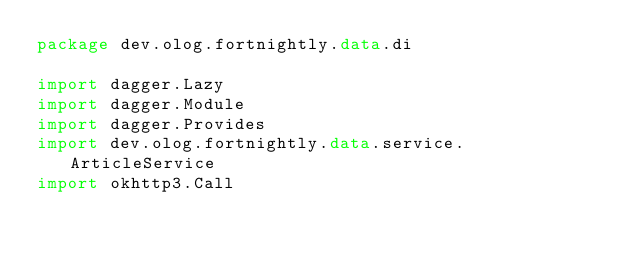<code> <loc_0><loc_0><loc_500><loc_500><_Kotlin_>package dev.olog.fortnightly.data.di

import dagger.Lazy
import dagger.Module
import dagger.Provides
import dev.olog.fortnightly.data.service.ArticleService
import okhttp3.Call</code> 